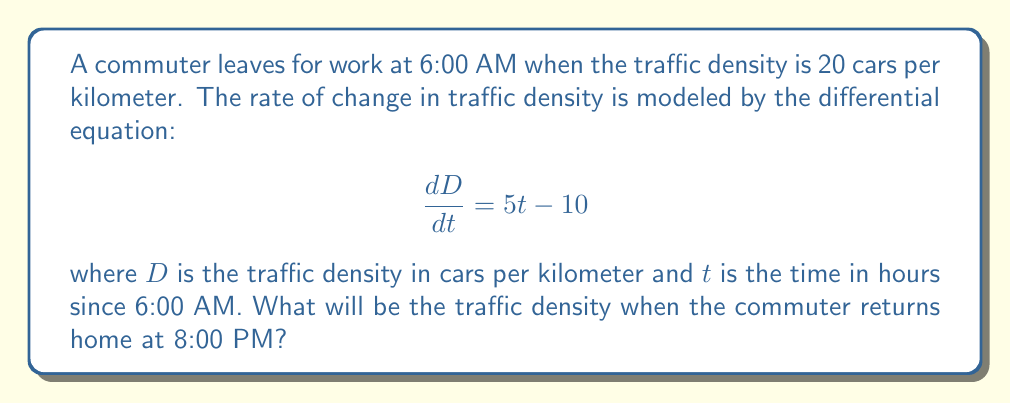Show me your answer to this math problem. To solve this problem, we need to follow these steps:

1) First, we need to integrate the given differential equation to find the function for traffic density $D(t)$.

   $$\frac{dD}{dt} = 5t - 10$$
   $$D = \int (5t - 10) dt = \frac{5t^2}{2} - 10t + C$$

2) To find the constant of integration $C$, we use the initial condition. At $t=0$ (6:00 AM), $D=20$.

   $$20 = \frac{5(0)^2}{2} - 10(0) + C$$
   $$20 = C$$

3) So, our function for traffic density is:

   $$D(t) = \frac{5t^2}{2} - 10t + 20$$

4) Now, we need to calculate the traffic density at 8:00 PM. This is 14 hours after 6:00 AM, so $t=14$.

   $$D(14) = \frac{5(14)^2}{2} - 10(14) + 20$$
   $$= \frac{5(196)}{2} - 140 + 20$$
   $$= 490 - 140 + 20$$
   $$= 370$$

Therefore, the traffic density at 8:00 PM will be 370 cars per kilometer.
Answer: 370 cars per kilometer 